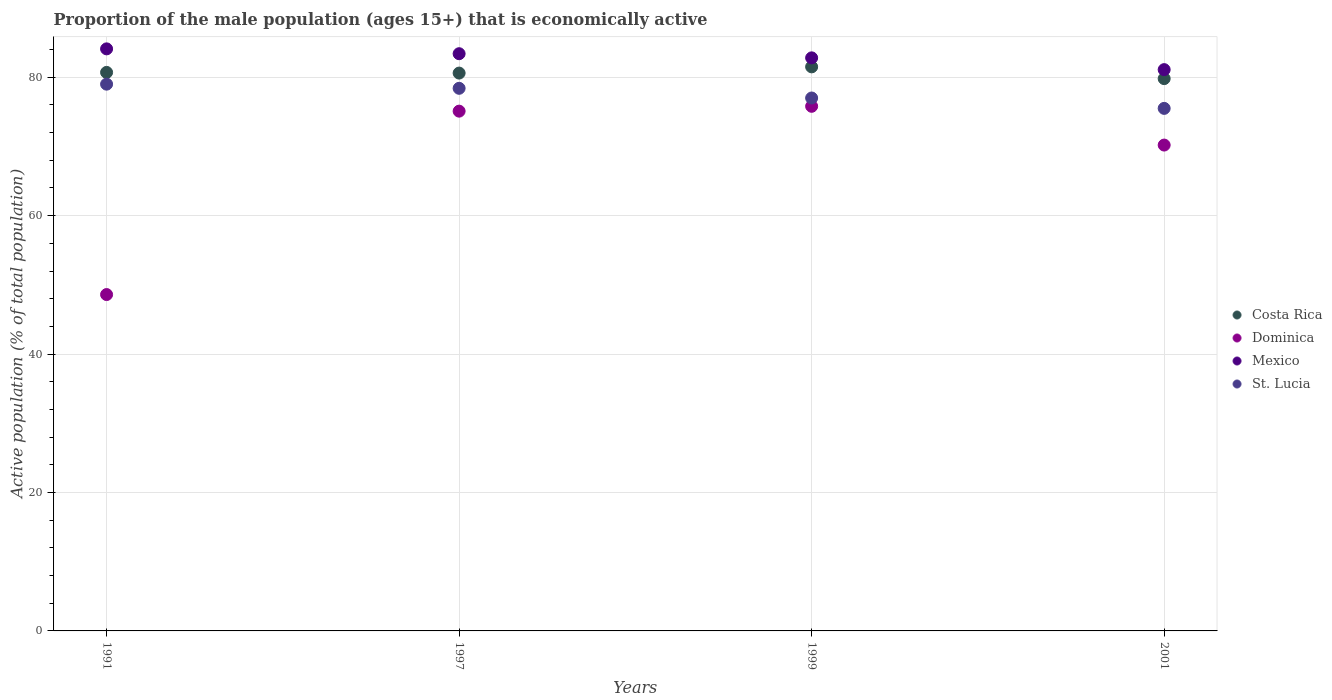What is the proportion of the male population that is economically active in Mexico in 1999?
Your answer should be very brief. 82.8. Across all years, what is the maximum proportion of the male population that is economically active in Dominica?
Offer a terse response. 75.8. Across all years, what is the minimum proportion of the male population that is economically active in Costa Rica?
Provide a succinct answer. 79.8. In which year was the proportion of the male population that is economically active in Dominica maximum?
Give a very brief answer. 1999. What is the total proportion of the male population that is economically active in Dominica in the graph?
Provide a short and direct response. 269.7. What is the difference between the proportion of the male population that is economically active in Costa Rica in 1997 and the proportion of the male population that is economically active in Dominica in 2001?
Your answer should be compact. 10.4. What is the average proportion of the male population that is economically active in Costa Rica per year?
Provide a short and direct response. 80.65. In the year 1999, what is the difference between the proportion of the male population that is economically active in Dominica and proportion of the male population that is economically active in Mexico?
Ensure brevity in your answer.  -7. What is the ratio of the proportion of the male population that is economically active in Mexico in 1991 to that in 1999?
Your answer should be compact. 1.02. Is the proportion of the male population that is economically active in Dominica in 1991 less than that in 1999?
Give a very brief answer. Yes. What is the difference between the highest and the second highest proportion of the male population that is economically active in St. Lucia?
Offer a terse response. 0.6. What is the difference between the highest and the lowest proportion of the male population that is economically active in Dominica?
Your answer should be compact. 27.2. In how many years, is the proportion of the male population that is economically active in St. Lucia greater than the average proportion of the male population that is economically active in St. Lucia taken over all years?
Your answer should be very brief. 2. Does the proportion of the male population that is economically active in Mexico monotonically increase over the years?
Offer a terse response. No. Is the proportion of the male population that is economically active in St. Lucia strictly greater than the proportion of the male population that is economically active in Costa Rica over the years?
Give a very brief answer. No. Is the proportion of the male population that is economically active in Mexico strictly less than the proportion of the male population that is economically active in Dominica over the years?
Your answer should be very brief. No. How many dotlines are there?
Ensure brevity in your answer.  4. How are the legend labels stacked?
Your answer should be very brief. Vertical. What is the title of the graph?
Your answer should be very brief. Proportion of the male population (ages 15+) that is economically active. What is the label or title of the X-axis?
Ensure brevity in your answer.  Years. What is the label or title of the Y-axis?
Provide a short and direct response. Active population (% of total population). What is the Active population (% of total population) of Costa Rica in 1991?
Offer a very short reply. 80.7. What is the Active population (% of total population) in Dominica in 1991?
Ensure brevity in your answer.  48.6. What is the Active population (% of total population) of Mexico in 1991?
Keep it short and to the point. 84.1. What is the Active population (% of total population) of St. Lucia in 1991?
Make the answer very short. 79. What is the Active population (% of total population) of Costa Rica in 1997?
Your response must be concise. 80.6. What is the Active population (% of total population) of Dominica in 1997?
Make the answer very short. 75.1. What is the Active population (% of total population) of Mexico in 1997?
Offer a very short reply. 83.4. What is the Active population (% of total population) in St. Lucia in 1997?
Your answer should be very brief. 78.4. What is the Active population (% of total population) of Costa Rica in 1999?
Make the answer very short. 81.5. What is the Active population (% of total population) in Dominica in 1999?
Offer a terse response. 75.8. What is the Active population (% of total population) of Mexico in 1999?
Your answer should be very brief. 82.8. What is the Active population (% of total population) in St. Lucia in 1999?
Give a very brief answer. 77. What is the Active population (% of total population) in Costa Rica in 2001?
Make the answer very short. 79.8. What is the Active population (% of total population) of Dominica in 2001?
Provide a short and direct response. 70.2. What is the Active population (% of total population) of Mexico in 2001?
Your response must be concise. 81.1. What is the Active population (% of total population) of St. Lucia in 2001?
Offer a terse response. 75.5. Across all years, what is the maximum Active population (% of total population) of Costa Rica?
Ensure brevity in your answer.  81.5. Across all years, what is the maximum Active population (% of total population) of Dominica?
Your answer should be compact. 75.8. Across all years, what is the maximum Active population (% of total population) in Mexico?
Offer a terse response. 84.1. Across all years, what is the maximum Active population (% of total population) of St. Lucia?
Your answer should be very brief. 79. Across all years, what is the minimum Active population (% of total population) in Costa Rica?
Offer a terse response. 79.8. Across all years, what is the minimum Active population (% of total population) of Dominica?
Give a very brief answer. 48.6. Across all years, what is the minimum Active population (% of total population) of Mexico?
Offer a terse response. 81.1. Across all years, what is the minimum Active population (% of total population) in St. Lucia?
Give a very brief answer. 75.5. What is the total Active population (% of total population) in Costa Rica in the graph?
Your answer should be compact. 322.6. What is the total Active population (% of total population) in Dominica in the graph?
Your answer should be compact. 269.7. What is the total Active population (% of total population) in Mexico in the graph?
Your answer should be very brief. 331.4. What is the total Active population (% of total population) of St. Lucia in the graph?
Keep it short and to the point. 309.9. What is the difference between the Active population (% of total population) of Costa Rica in 1991 and that in 1997?
Your answer should be very brief. 0.1. What is the difference between the Active population (% of total population) in Dominica in 1991 and that in 1997?
Your response must be concise. -26.5. What is the difference between the Active population (% of total population) in Costa Rica in 1991 and that in 1999?
Make the answer very short. -0.8. What is the difference between the Active population (% of total population) of Dominica in 1991 and that in 1999?
Provide a short and direct response. -27.2. What is the difference between the Active population (% of total population) of Mexico in 1991 and that in 1999?
Your answer should be compact. 1.3. What is the difference between the Active population (% of total population) of Dominica in 1991 and that in 2001?
Your answer should be compact. -21.6. What is the difference between the Active population (% of total population) of Dominica in 1997 and that in 1999?
Make the answer very short. -0.7. What is the difference between the Active population (% of total population) of St. Lucia in 1997 and that in 1999?
Your response must be concise. 1.4. What is the difference between the Active population (% of total population) in St. Lucia in 1997 and that in 2001?
Offer a very short reply. 2.9. What is the difference between the Active population (% of total population) of Costa Rica in 1999 and that in 2001?
Ensure brevity in your answer.  1.7. What is the difference between the Active population (% of total population) in St. Lucia in 1999 and that in 2001?
Provide a short and direct response. 1.5. What is the difference between the Active population (% of total population) of Costa Rica in 1991 and the Active population (% of total population) of Dominica in 1997?
Your response must be concise. 5.6. What is the difference between the Active population (% of total population) in Dominica in 1991 and the Active population (% of total population) in Mexico in 1997?
Give a very brief answer. -34.8. What is the difference between the Active population (% of total population) in Dominica in 1991 and the Active population (% of total population) in St. Lucia in 1997?
Offer a very short reply. -29.8. What is the difference between the Active population (% of total population) in Costa Rica in 1991 and the Active population (% of total population) in Mexico in 1999?
Provide a succinct answer. -2.1. What is the difference between the Active population (% of total population) in Costa Rica in 1991 and the Active population (% of total population) in St. Lucia in 1999?
Keep it short and to the point. 3.7. What is the difference between the Active population (% of total population) of Dominica in 1991 and the Active population (% of total population) of Mexico in 1999?
Your answer should be compact. -34.2. What is the difference between the Active population (% of total population) in Dominica in 1991 and the Active population (% of total population) in St. Lucia in 1999?
Provide a succinct answer. -28.4. What is the difference between the Active population (% of total population) of Mexico in 1991 and the Active population (% of total population) of St. Lucia in 1999?
Ensure brevity in your answer.  7.1. What is the difference between the Active population (% of total population) of Costa Rica in 1991 and the Active population (% of total population) of St. Lucia in 2001?
Your response must be concise. 5.2. What is the difference between the Active population (% of total population) in Dominica in 1991 and the Active population (% of total population) in Mexico in 2001?
Your response must be concise. -32.5. What is the difference between the Active population (% of total population) of Dominica in 1991 and the Active population (% of total population) of St. Lucia in 2001?
Ensure brevity in your answer.  -26.9. What is the difference between the Active population (% of total population) in Costa Rica in 1997 and the Active population (% of total population) in Mexico in 1999?
Give a very brief answer. -2.2. What is the difference between the Active population (% of total population) in Costa Rica in 1997 and the Active population (% of total population) in St. Lucia in 1999?
Your answer should be compact. 3.6. What is the difference between the Active population (% of total population) in Costa Rica in 1997 and the Active population (% of total population) in Mexico in 2001?
Offer a very short reply. -0.5. What is the difference between the Active population (% of total population) in Dominica in 1997 and the Active population (% of total population) in St. Lucia in 2001?
Your answer should be very brief. -0.4. What is the difference between the Active population (% of total population) in Mexico in 1997 and the Active population (% of total population) in St. Lucia in 2001?
Give a very brief answer. 7.9. What is the difference between the Active population (% of total population) of Costa Rica in 1999 and the Active population (% of total population) of Dominica in 2001?
Ensure brevity in your answer.  11.3. What is the difference between the Active population (% of total population) of Dominica in 1999 and the Active population (% of total population) of Mexico in 2001?
Offer a very short reply. -5.3. What is the average Active population (% of total population) of Costa Rica per year?
Your answer should be very brief. 80.65. What is the average Active population (% of total population) in Dominica per year?
Your answer should be compact. 67.42. What is the average Active population (% of total population) in Mexico per year?
Your answer should be very brief. 82.85. What is the average Active population (% of total population) in St. Lucia per year?
Your answer should be very brief. 77.47. In the year 1991, what is the difference between the Active population (% of total population) of Costa Rica and Active population (% of total population) of Dominica?
Your response must be concise. 32.1. In the year 1991, what is the difference between the Active population (% of total population) of Dominica and Active population (% of total population) of Mexico?
Provide a short and direct response. -35.5. In the year 1991, what is the difference between the Active population (% of total population) of Dominica and Active population (% of total population) of St. Lucia?
Your answer should be compact. -30.4. In the year 1997, what is the difference between the Active population (% of total population) of Costa Rica and Active population (% of total population) of Mexico?
Ensure brevity in your answer.  -2.8. In the year 1997, what is the difference between the Active population (% of total population) of Dominica and Active population (% of total population) of Mexico?
Offer a very short reply. -8.3. In the year 1997, what is the difference between the Active population (% of total population) in Dominica and Active population (% of total population) in St. Lucia?
Offer a terse response. -3.3. In the year 1997, what is the difference between the Active population (% of total population) of Mexico and Active population (% of total population) of St. Lucia?
Make the answer very short. 5. In the year 1999, what is the difference between the Active population (% of total population) in Costa Rica and Active population (% of total population) in Mexico?
Provide a short and direct response. -1.3. In the year 1999, what is the difference between the Active population (% of total population) in Dominica and Active population (% of total population) in St. Lucia?
Your answer should be compact. -1.2. In the year 2001, what is the difference between the Active population (% of total population) in Costa Rica and Active population (% of total population) in Mexico?
Make the answer very short. -1.3. In the year 2001, what is the difference between the Active population (% of total population) of Dominica and Active population (% of total population) of Mexico?
Your answer should be very brief. -10.9. In the year 2001, what is the difference between the Active population (% of total population) in Mexico and Active population (% of total population) in St. Lucia?
Ensure brevity in your answer.  5.6. What is the ratio of the Active population (% of total population) in Costa Rica in 1991 to that in 1997?
Your answer should be very brief. 1. What is the ratio of the Active population (% of total population) of Dominica in 1991 to that in 1997?
Give a very brief answer. 0.65. What is the ratio of the Active population (% of total population) of Mexico in 1991 to that in 1997?
Make the answer very short. 1.01. What is the ratio of the Active population (% of total population) of St. Lucia in 1991 to that in 1997?
Provide a short and direct response. 1.01. What is the ratio of the Active population (% of total population) of Costa Rica in 1991 to that in 1999?
Keep it short and to the point. 0.99. What is the ratio of the Active population (% of total population) of Dominica in 1991 to that in 1999?
Make the answer very short. 0.64. What is the ratio of the Active population (% of total population) of Mexico in 1991 to that in 1999?
Provide a succinct answer. 1.02. What is the ratio of the Active population (% of total population) of St. Lucia in 1991 to that in 1999?
Your answer should be very brief. 1.03. What is the ratio of the Active population (% of total population) in Costa Rica in 1991 to that in 2001?
Keep it short and to the point. 1.01. What is the ratio of the Active population (% of total population) of Dominica in 1991 to that in 2001?
Your answer should be compact. 0.69. What is the ratio of the Active population (% of total population) of Mexico in 1991 to that in 2001?
Your response must be concise. 1.04. What is the ratio of the Active population (% of total population) in St. Lucia in 1991 to that in 2001?
Keep it short and to the point. 1.05. What is the ratio of the Active population (% of total population) in Dominica in 1997 to that in 1999?
Your response must be concise. 0.99. What is the ratio of the Active population (% of total population) in St. Lucia in 1997 to that in 1999?
Offer a terse response. 1.02. What is the ratio of the Active population (% of total population) in Dominica in 1997 to that in 2001?
Provide a short and direct response. 1.07. What is the ratio of the Active population (% of total population) of Mexico in 1997 to that in 2001?
Your response must be concise. 1.03. What is the ratio of the Active population (% of total population) in St. Lucia in 1997 to that in 2001?
Make the answer very short. 1.04. What is the ratio of the Active population (% of total population) of Costa Rica in 1999 to that in 2001?
Make the answer very short. 1.02. What is the ratio of the Active population (% of total population) of Dominica in 1999 to that in 2001?
Offer a very short reply. 1.08. What is the ratio of the Active population (% of total population) of St. Lucia in 1999 to that in 2001?
Your answer should be compact. 1.02. What is the difference between the highest and the second highest Active population (% of total population) of Mexico?
Your response must be concise. 0.7. What is the difference between the highest and the second highest Active population (% of total population) of St. Lucia?
Give a very brief answer. 0.6. What is the difference between the highest and the lowest Active population (% of total population) of Dominica?
Your response must be concise. 27.2. What is the difference between the highest and the lowest Active population (% of total population) in Mexico?
Your response must be concise. 3. What is the difference between the highest and the lowest Active population (% of total population) of St. Lucia?
Offer a terse response. 3.5. 